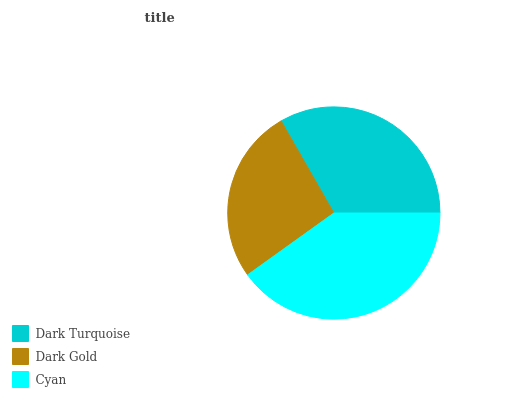Is Dark Gold the minimum?
Answer yes or no. Yes. Is Cyan the maximum?
Answer yes or no. Yes. Is Cyan the minimum?
Answer yes or no. No. Is Dark Gold the maximum?
Answer yes or no. No. Is Cyan greater than Dark Gold?
Answer yes or no. Yes. Is Dark Gold less than Cyan?
Answer yes or no. Yes. Is Dark Gold greater than Cyan?
Answer yes or no. No. Is Cyan less than Dark Gold?
Answer yes or no. No. Is Dark Turquoise the high median?
Answer yes or no. Yes. Is Dark Turquoise the low median?
Answer yes or no. Yes. Is Dark Gold the high median?
Answer yes or no. No. Is Dark Gold the low median?
Answer yes or no. No. 